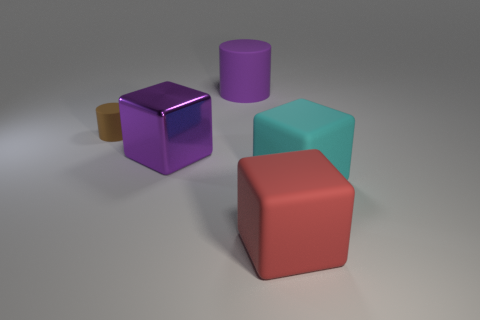Add 5 red shiny blocks. How many objects exist? 10 Subtract all cylinders. How many objects are left? 3 Subtract all big cylinders. Subtract all cyan matte objects. How many objects are left? 3 Add 2 cyan blocks. How many cyan blocks are left? 3 Add 3 big metallic things. How many big metallic things exist? 4 Subtract 0 blue spheres. How many objects are left? 5 